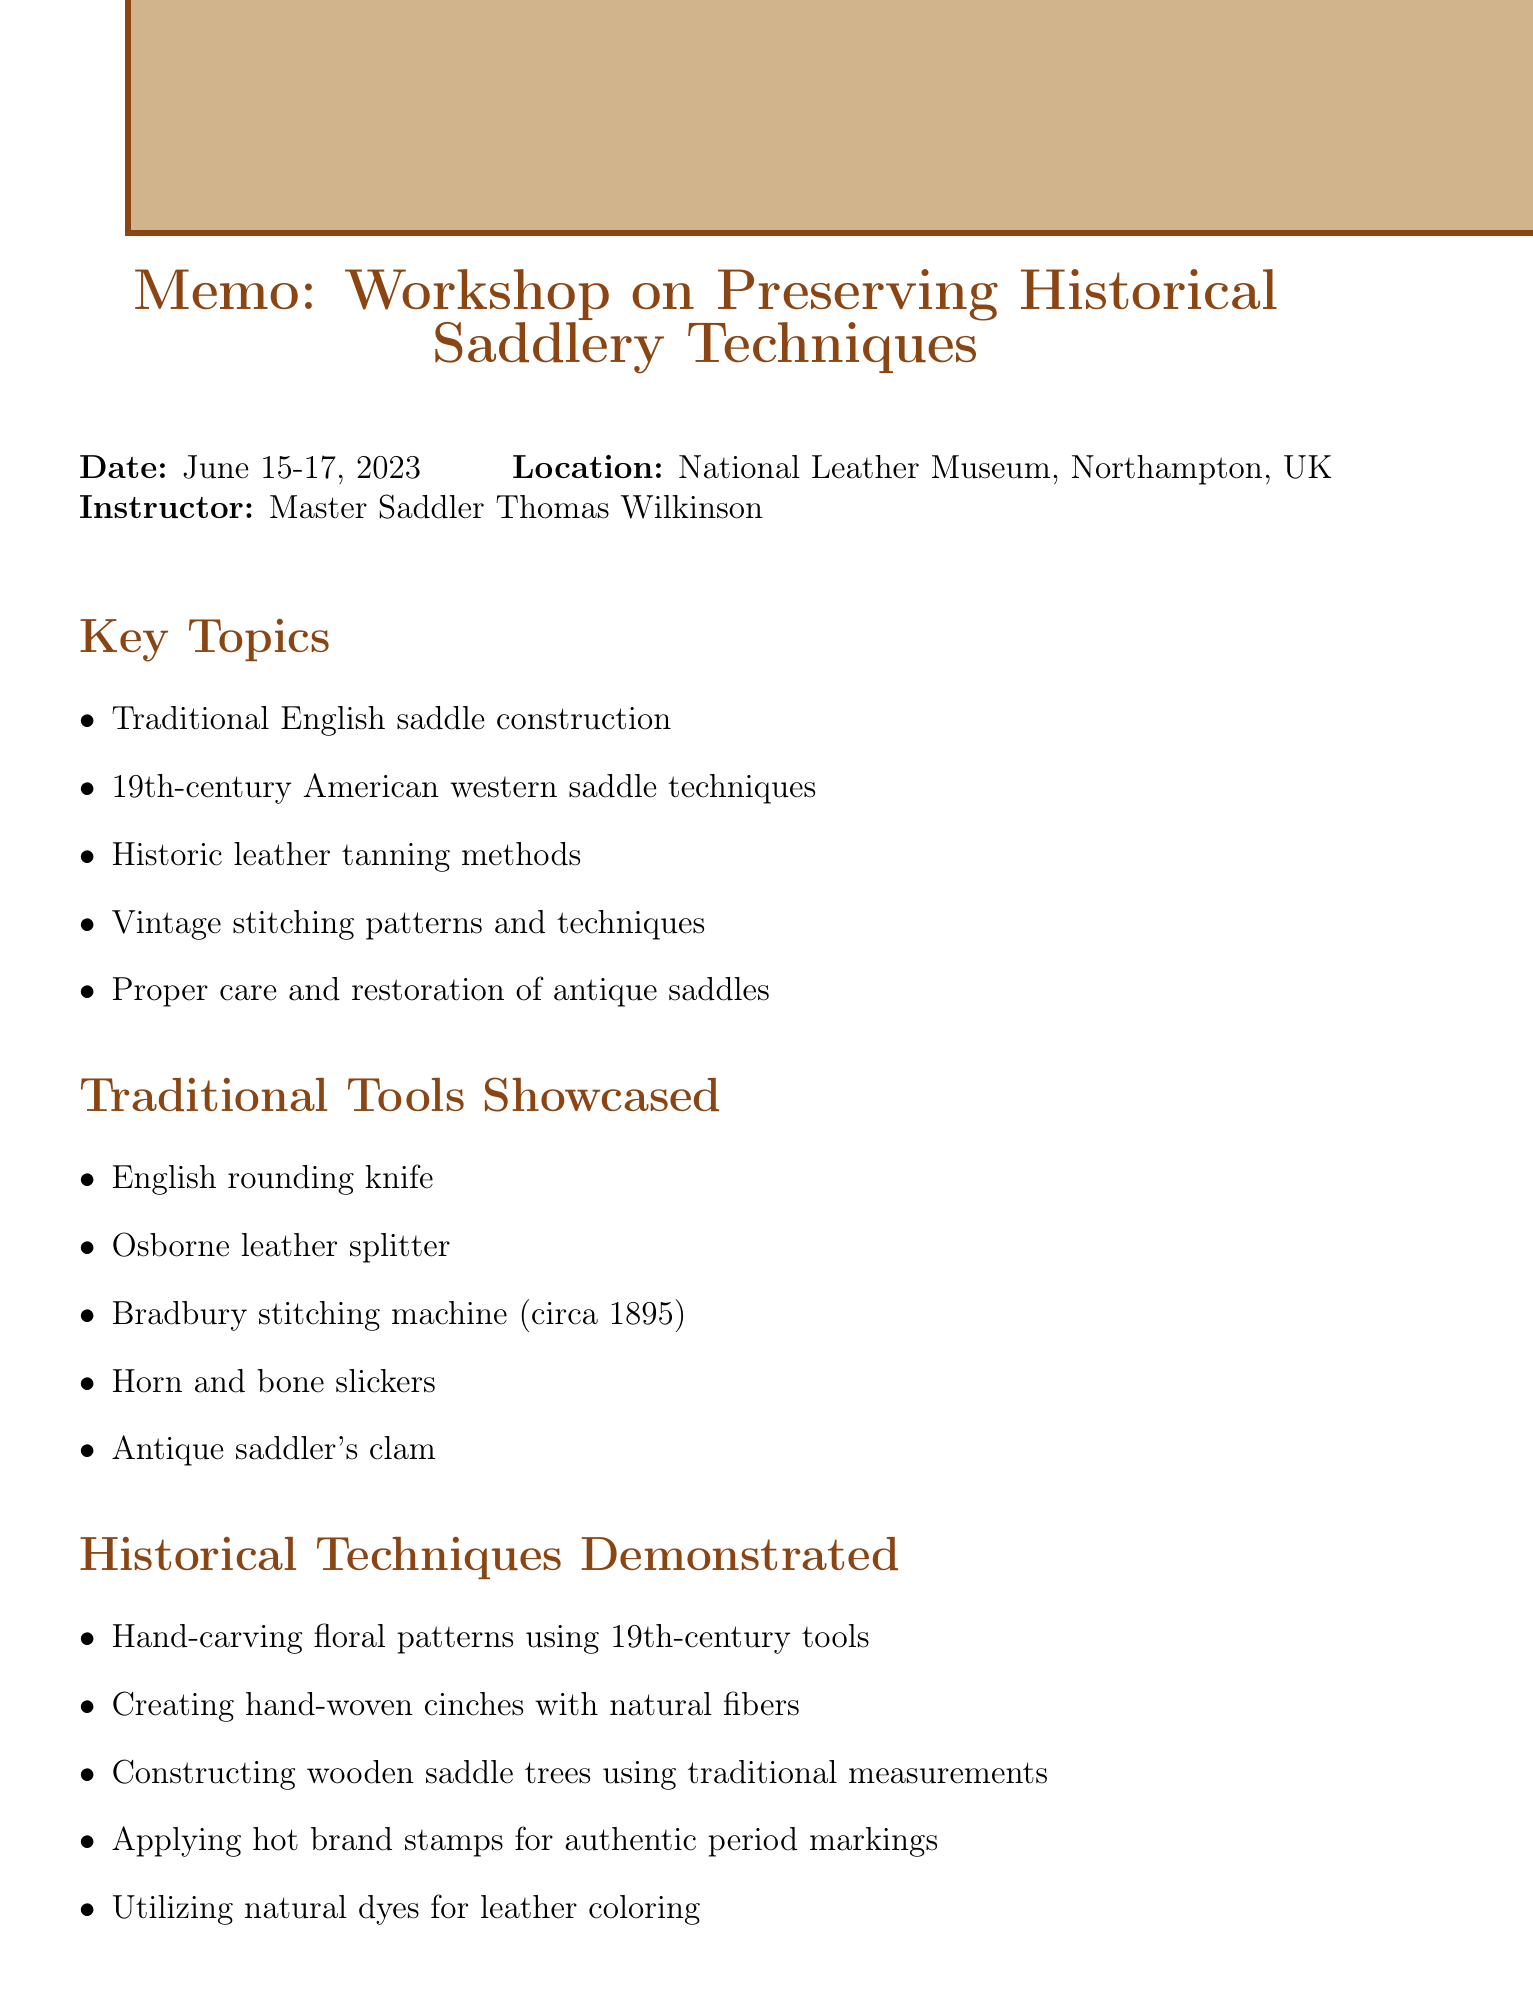What is the title of the workshop? The title is mentioned at the beginning of the document as "Workshop on Preserving Historical Saddlery Techniques."
Answer: Preserving Historical Saddlery Techniques Who is the instructor of the workshop? The instructor's name is provided in the workshop details section of the document.
Answer: Master Saddler Thomas Wilkinson What are the dates of the workshop? The dates are specifically stated in the workshop details.
Answer: June 15-17, 2023 Which traditional tool is associated with leather splitting? The document lists traditional tools and indicates which tool is used for splitting leather.
Answer: Osborne leather splitter What type of leather was showcased in the materials? The materials showcased in the document include different types, one of which is identified clearly.
Answer: Full-grain vegetable-tanned leather from J&E Sedgwick & Co What preservation method is mentioned for preventing leather degradation? The preservation methods section provides specific techniques, including one for storage.
Answer: Proper storage techniques to prevent leather degradation How many key topics were covered in the workshop? The number of key topics can be counted in the key topics section of the document.
Answer: Five What characteristic of hand-stitching is highlighted in personal observations? The personal observations mention a specific quality of hand-stitching compared to machine work.
Answer: Durability Who were some notable attendees at the workshop? Notable attendees are listed in the document, showcasing various organizations and individuals.
Answer: Representatives from the Royal Mews, Curators from the Smithsonian National Museum of American History, Master craftsmen from Hermès leather goods, Members of the Society for Creative Anachronism, Conservators from various equestrian museums worldwide 